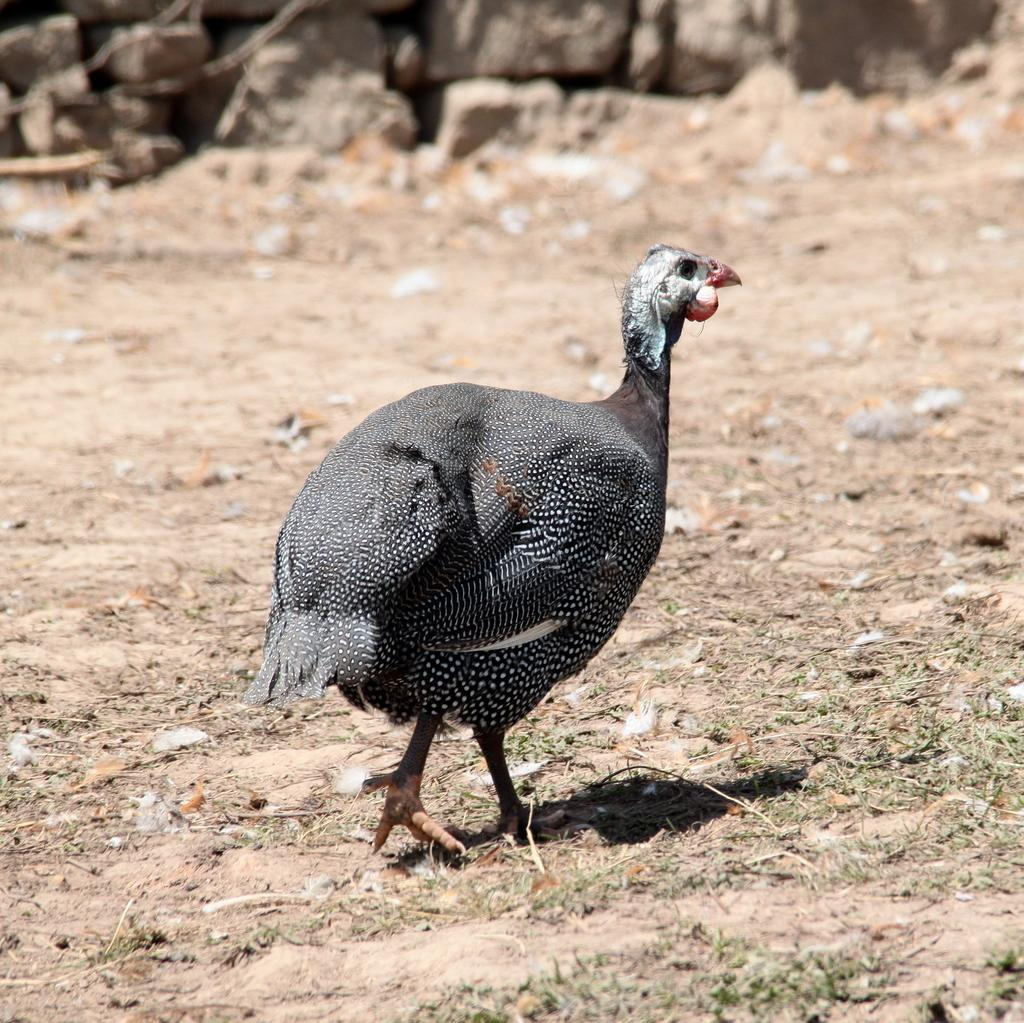What type of surface is visible in the image? There is a mud surface in the image. What animal can be seen on the mud surface? There is a black hen with white dots in the image. What can be seen in the background of the image? There are rocks visible in the background of the image. What type of brass instrument is being played by the hen in the image? There is no brass instrument or any indication of music in the image; it features a black hen with white dots on a mud surface with rocks in the background. 